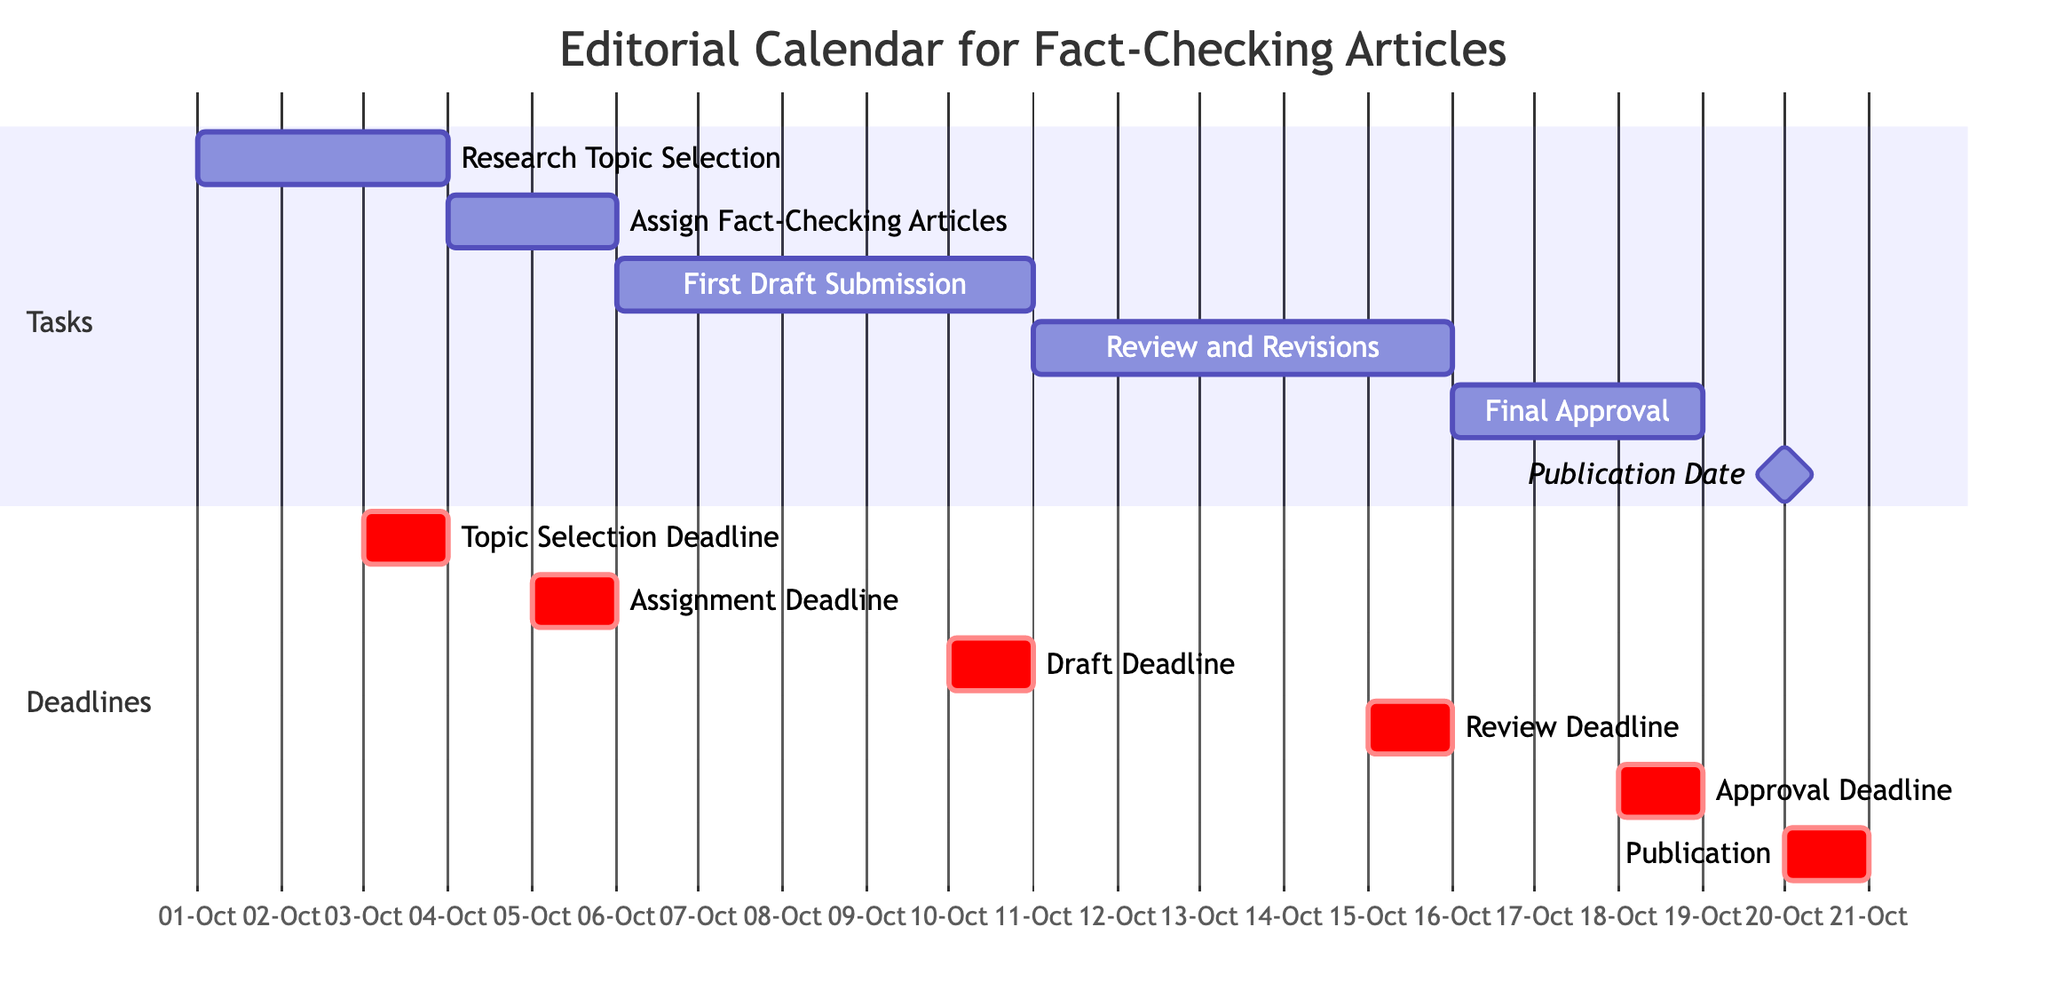What is the first task in the editorial calendar? The first task listed in the Gantt chart is "Research Topic Selection," as it appears at the top of the timeline.
Answer: Research Topic Selection What is the duration of the "Review and Revisions" task? The "Review and Revisions" task starts on October 11 and ends on October 15, which is a total of 5 days.
Answer: 5 days When is the "First Draft Submission" due? The "First Draft Submission" has an end date of October 10, making it the deadline for this task.
Answer: October 10 How many critical deadlines are there in the Gantt chart? There are 6 critical deadlines listed in the Gantt chart, each corresponding to the completion of different tasks.
Answer: 6 What task follows the "Final Approval" in terms of timeline? The next task after "Final Approval" is "Publication Date," which occurs immediately after on October 20.
Answer: Publication Date What is the start date of the "Assign Fact-Checking Articles" task? The start date for the "Assign Fact-Checking Articles" task is October 4.
Answer: October 4 What is the total time frame from the start of the first task to the publication date? The entire time frame of the project is from October 1 (start of "Research Topic Selection") to October 20 (the day of "Publication Date"), which is a total of 20 days.
Answer: 20 days Which task has the earliest completion date in the chart? The earliest completion date belongs to "Research Topic Selection," which is completed by October 3.
Answer: Research Topic Selection What does the term "milestone" refer to in the context of this chart? The term "milestone" in this Gantt chart indicates a significant event or phase completion, specifically the "Publication Date."
Answer: Publication Date 